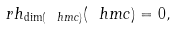Convert formula to latex. <formula><loc_0><loc_0><loc_500><loc_500>\ r h _ { \dim ( \ h m c ) } ( \ h m c ) = 0 ,</formula> 